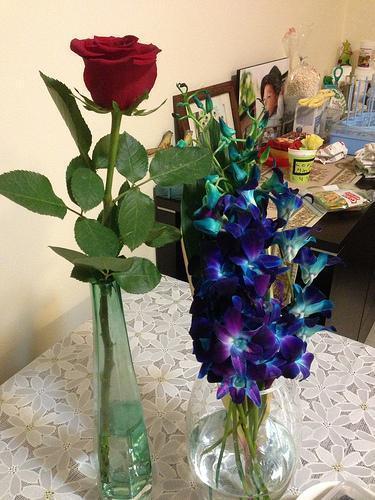How many vases?
Give a very brief answer. 2. How many vases are on the table?
Give a very brief answer. 2. 